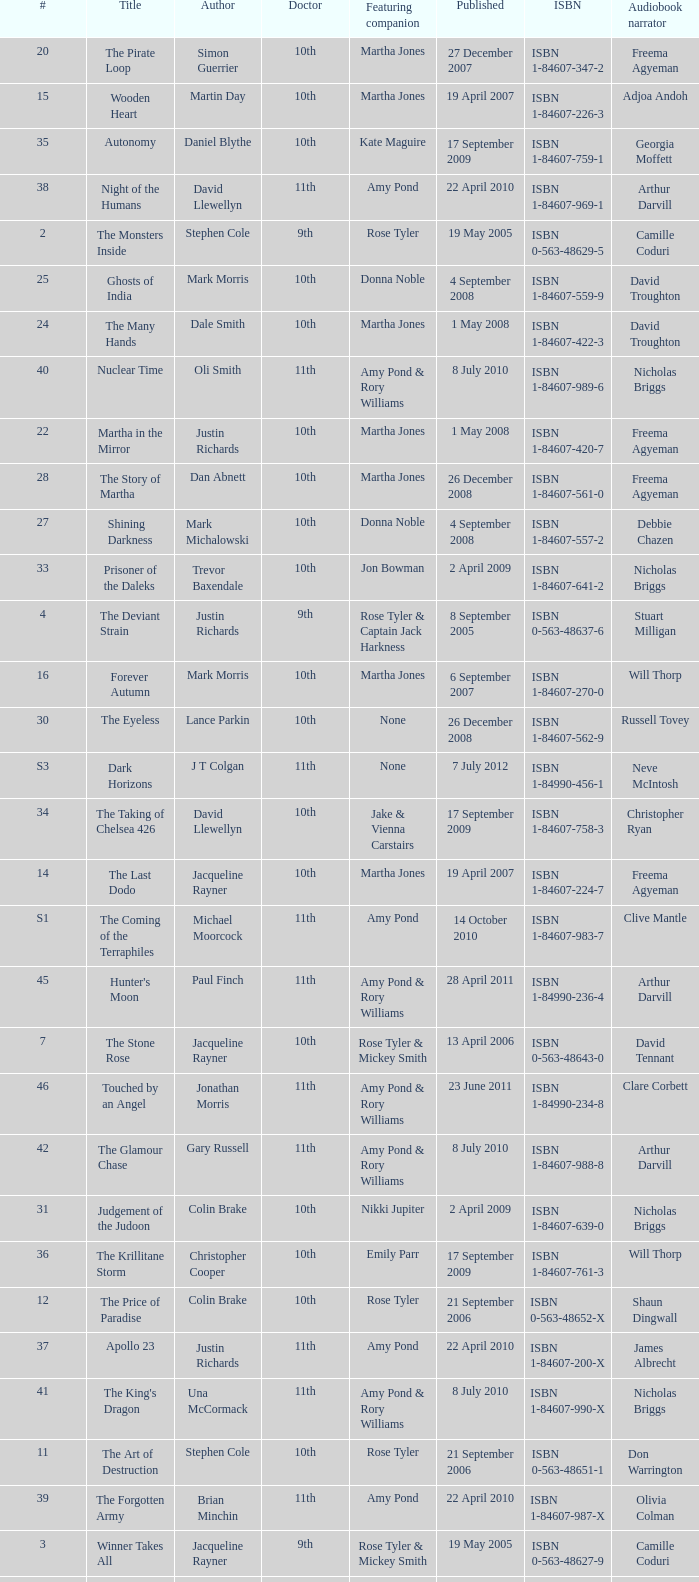What is the publication date of the book that is narrated by Michael Maloney? 29 September 2011. 